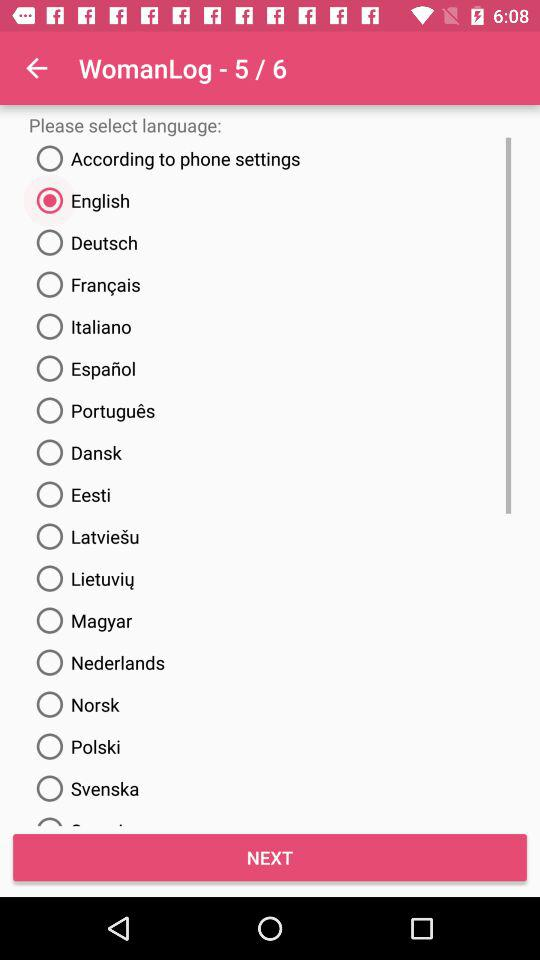Which language has been selected? The selected language is English. 